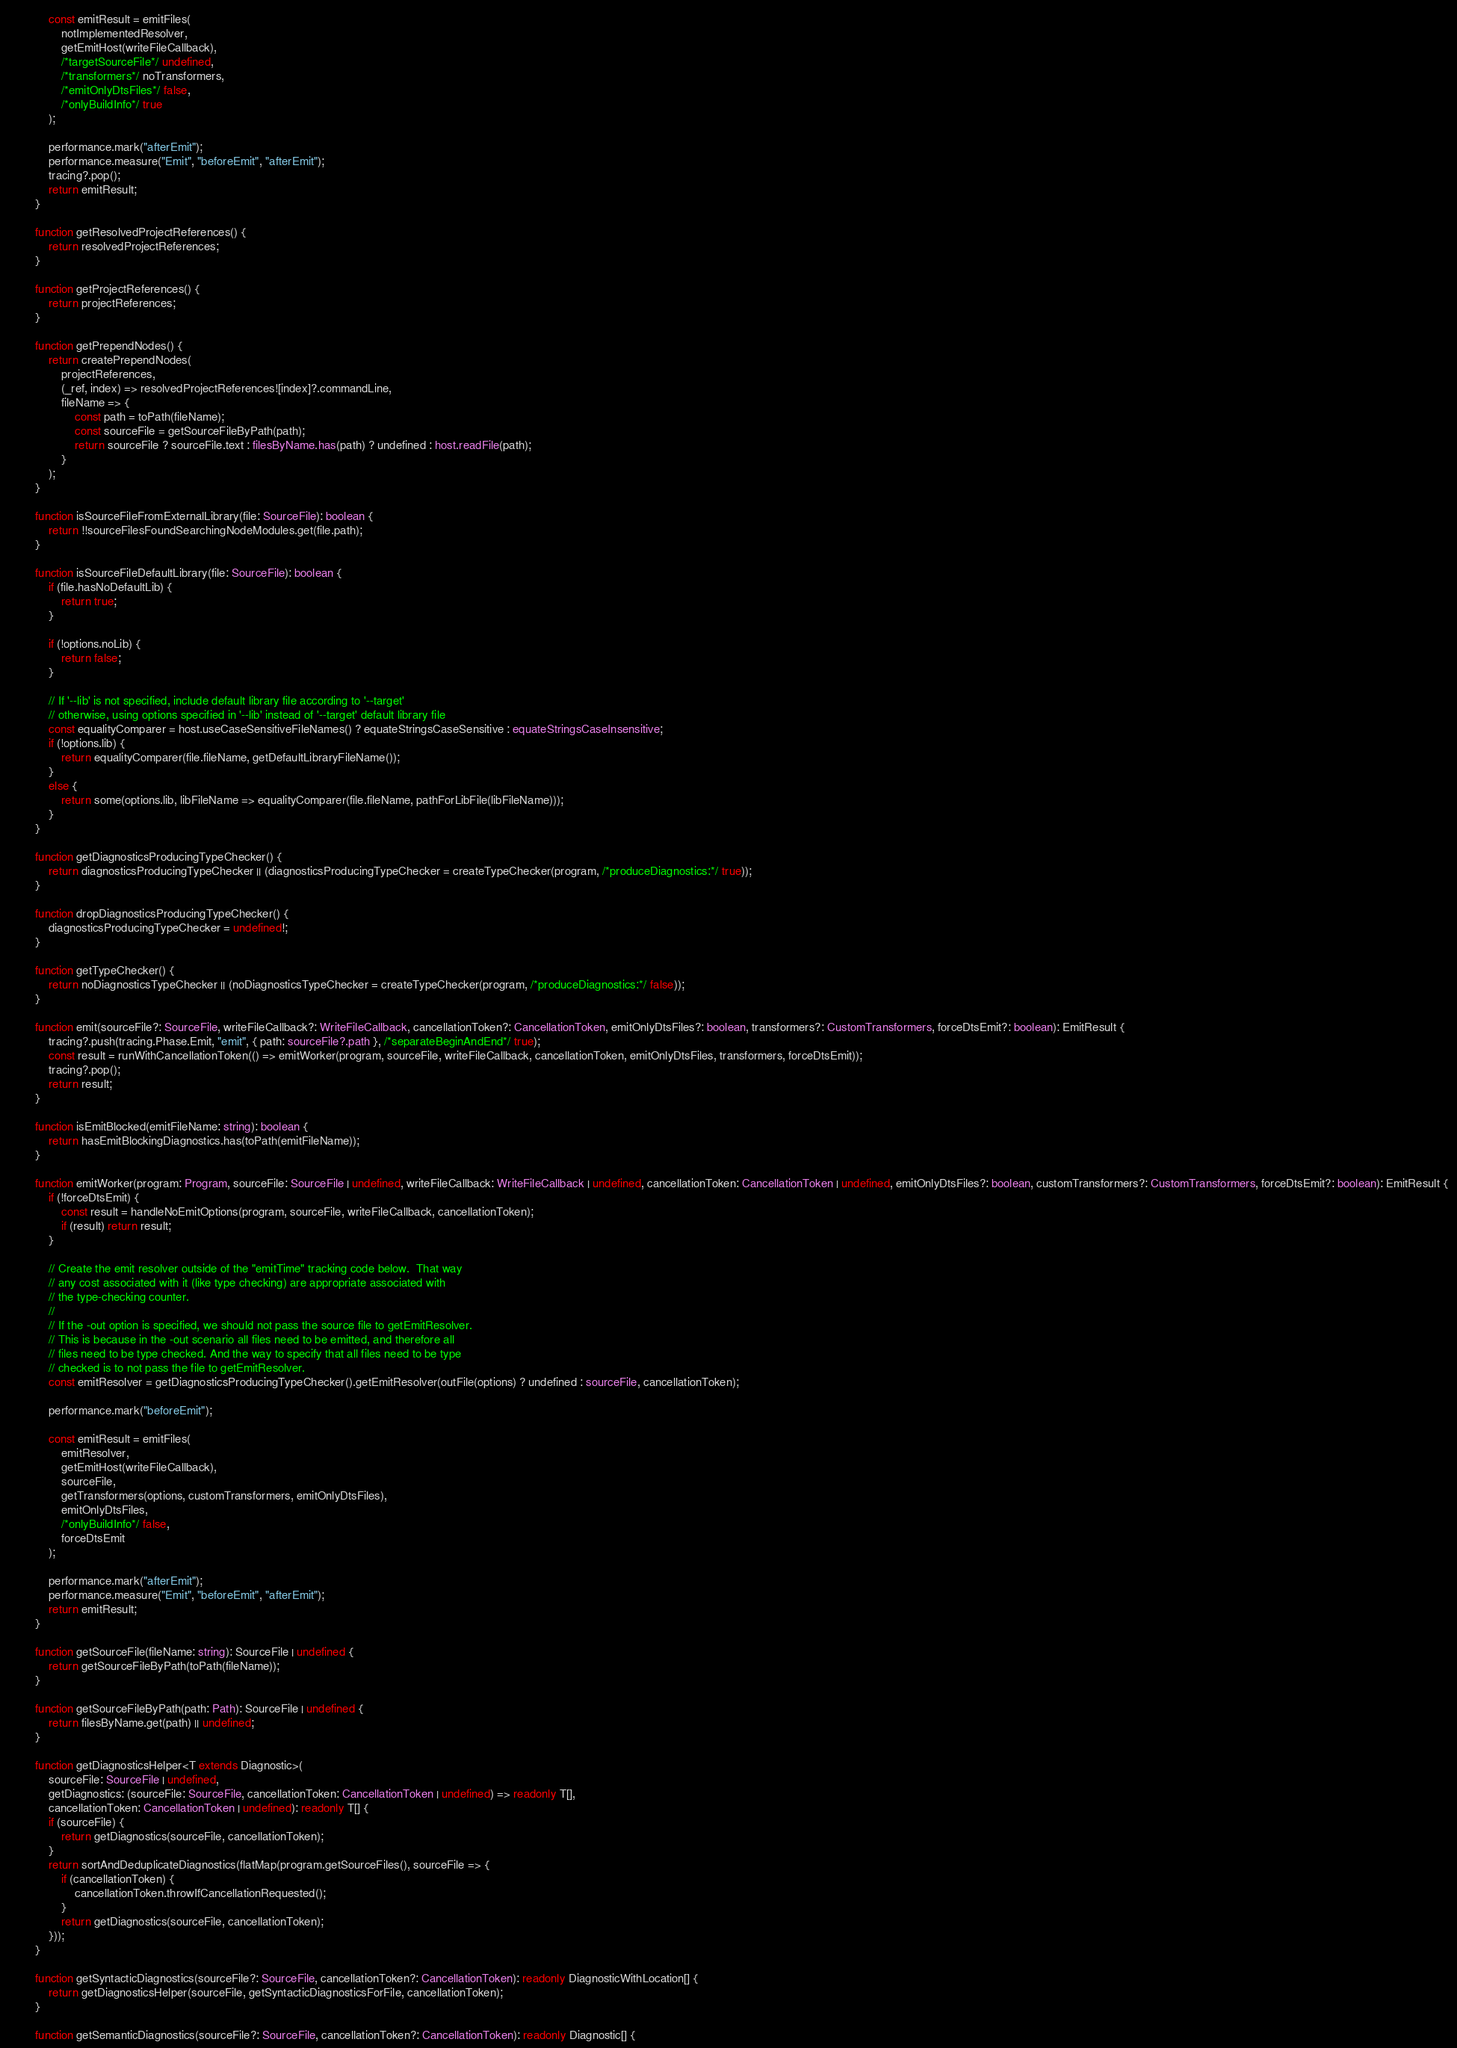<code> <loc_0><loc_0><loc_500><loc_500><_TypeScript_>            const emitResult = emitFiles(
                notImplementedResolver,
                getEmitHost(writeFileCallback),
                /*targetSourceFile*/ undefined,
                /*transformers*/ noTransformers,
                /*emitOnlyDtsFiles*/ false,
                /*onlyBuildInfo*/ true
            );

            performance.mark("afterEmit");
            performance.measure("Emit", "beforeEmit", "afterEmit");
            tracing?.pop();
            return emitResult;
        }

        function getResolvedProjectReferences() {
            return resolvedProjectReferences;
        }

        function getProjectReferences() {
            return projectReferences;
        }

        function getPrependNodes() {
            return createPrependNodes(
                projectReferences,
                (_ref, index) => resolvedProjectReferences![index]?.commandLine,
                fileName => {
                    const path = toPath(fileName);
                    const sourceFile = getSourceFileByPath(path);
                    return sourceFile ? sourceFile.text : filesByName.has(path) ? undefined : host.readFile(path);
                }
            );
        }

        function isSourceFileFromExternalLibrary(file: SourceFile): boolean {
            return !!sourceFilesFoundSearchingNodeModules.get(file.path);
        }

        function isSourceFileDefaultLibrary(file: SourceFile): boolean {
            if (file.hasNoDefaultLib) {
                return true;
            }

            if (!options.noLib) {
                return false;
            }

            // If '--lib' is not specified, include default library file according to '--target'
            // otherwise, using options specified in '--lib' instead of '--target' default library file
            const equalityComparer = host.useCaseSensitiveFileNames() ? equateStringsCaseSensitive : equateStringsCaseInsensitive;
            if (!options.lib) {
                return equalityComparer(file.fileName, getDefaultLibraryFileName());
            }
            else {
                return some(options.lib, libFileName => equalityComparer(file.fileName, pathForLibFile(libFileName)));
            }
        }

        function getDiagnosticsProducingTypeChecker() {
            return diagnosticsProducingTypeChecker || (diagnosticsProducingTypeChecker = createTypeChecker(program, /*produceDiagnostics:*/ true));
        }

        function dropDiagnosticsProducingTypeChecker() {
            diagnosticsProducingTypeChecker = undefined!;
        }

        function getTypeChecker() {
            return noDiagnosticsTypeChecker || (noDiagnosticsTypeChecker = createTypeChecker(program, /*produceDiagnostics:*/ false));
        }

        function emit(sourceFile?: SourceFile, writeFileCallback?: WriteFileCallback, cancellationToken?: CancellationToken, emitOnlyDtsFiles?: boolean, transformers?: CustomTransformers, forceDtsEmit?: boolean): EmitResult {
            tracing?.push(tracing.Phase.Emit, "emit", { path: sourceFile?.path }, /*separateBeginAndEnd*/ true);
            const result = runWithCancellationToken(() => emitWorker(program, sourceFile, writeFileCallback, cancellationToken, emitOnlyDtsFiles, transformers, forceDtsEmit));
            tracing?.pop();
            return result;
        }

        function isEmitBlocked(emitFileName: string): boolean {
            return hasEmitBlockingDiagnostics.has(toPath(emitFileName));
        }

        function emitWorker(program: Program, sourceFile: SourceFile | undefined, writeFileCallback: WriteFileCallback | undefined, cancellationToken: CancellationToken | undefined, emitOnlyDtsFiles?: boolean, customTransformers?: CustomTransformers, forceDtsEmit?: boolean): EmitResult {
            if (!forceDtsEmit) {
                const result = handleNoEmitOptions(program, sourceFile, writeFileCallback, cancellationToken);
                if (result) return result;
            }

            // Create the emit resolver outside of the "emitTime" tracking code below.  That way
            // any cost associated with it (like type checking) are appropriate associated with
            // the type-checking counter.
            //
            // If the -out option is specified, we should not pass the source file to getEmitResolver.
            // This is because in the -out scenario all files need to be emitted, and therefore all
            // files need to be type checked. And the way to specify that all files need to be type
            // checked is to not pass the file to getEmitResolver.
            const emitResolver = getDiagnosticsProducingTypeChecker().getEmitResolver(outFile(options) ? undefined : sourceFile, cancellationToken);

            performance.mark("beforeEmit");

            const emitResult = emitFiles(
                emitResolver,
                getEmitHost(writeFileCallback),
                sourceFile,
                getTransformers(options, customTransformers, emitOnlyDtsFiles),
                emitOnlyDtsFiles,
                /*onlyBuildInfo*/ false,
                forceDtsEmit
            );

            performance.mark("afterEmit");
            performance.measure("Emit", "beforeEmit", "afterEmit");
            return emitResult;
        }

        function getSourceFile(fileName: string): SourceFile | undefined {
            return getSourceFileByPath(toPath(fileName));
        }

        function getSourceFileByPath(path: Path): SourceFile | undefined {
            return filesByName.get(path) || undefined;
        }

        function getDiagnosticsHelper<T extends Diagnostic>(
            sourceFile: SourceFile | undefined,
            getDiagnostics: (sourceFile: SourceFile, cancellationToken: CancellationToken | undefined) => readonly T[],
            cancellationToken: CancellationToken | undefined): readonly T[] {
            if (sourceFile) {
                return getDiagnostics(sourceFile, cancellationToken);
            }
            return sortAndDeduplicateDiagnostics(flatMap(program.getSourceFiles(), sourceFile => {
                if (cancellationToken) {
                    cancellationToken.throwIfCancellationRequested();
                }
                return getDiagnostics(sourceFile, cancellationToken);
            }));
        }

        function getSyntacticDiagnostics(sourceFile?: SourceFile, cancellationToken?: CancellationToken): readonly DiagnosticWithLocation[] {
            return getDiagnosticsHelper(sourceFile, getSyntacticDiagnosticsForFile, cancellationToken);
        }

        function getSemanticDiagnostics(sourceFile?: SourceFile, cancellationToken?: CancellationToken): readonly Diagnostic[] {</code> 